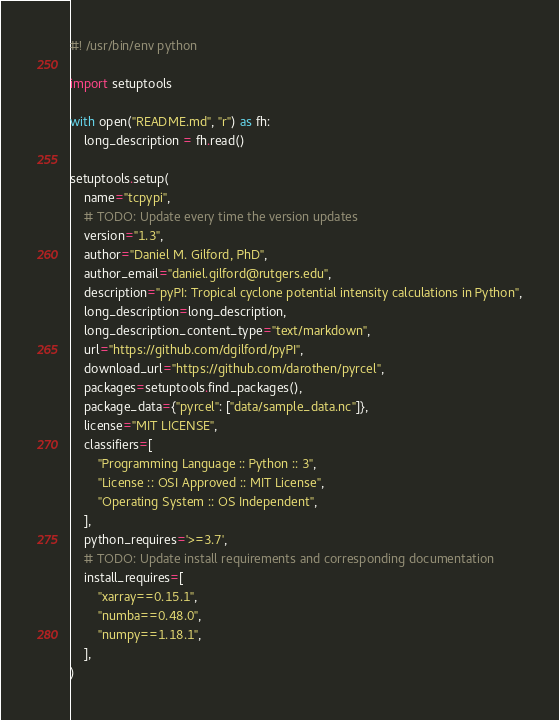Convert code to text. <code><loc_0><loc_0><loc_500><loc_500><_Python_>#! /usr/bin/env python

import setuptools

with open("README.md", "r") as fh:
    long_description = fh.read()

setuptools.setup(
    name="tcpypi",
    # TODO: Update every time the version updates
    version="1.3",
    author="Daniel M. Gilford, PhD",
    author_email="daniel.gilford@rutgers.edu",
    description="pyPI: Tropical cyclone potential intensity calculations in Python",
    long_description=long_description,
    long_description_content_type="text/markdown",
    url="https://github.com/dgilford/pyPI",
    download_url="https://github.com/darothen/pyrcel",
    packages=setuptools.find_packages(),
    package_data={"pyrcel": ["data/sample_data.nc"]},
    license="MIT LICENSE",
    classifiers=[
        "Programming Language :: Python :: 3",
        "License :: OSI Approved :: MIT License",
        "Operating System :: OS Independent",
    ],
    python_requires='>=3.7',
    # TODO: Update install requirements and corresponding documentation
    install_requires=[
        "xarray==0.15.1",
        "numba==0.48.0",
        "numpy==1.18.1",
    ],
)



</code> 